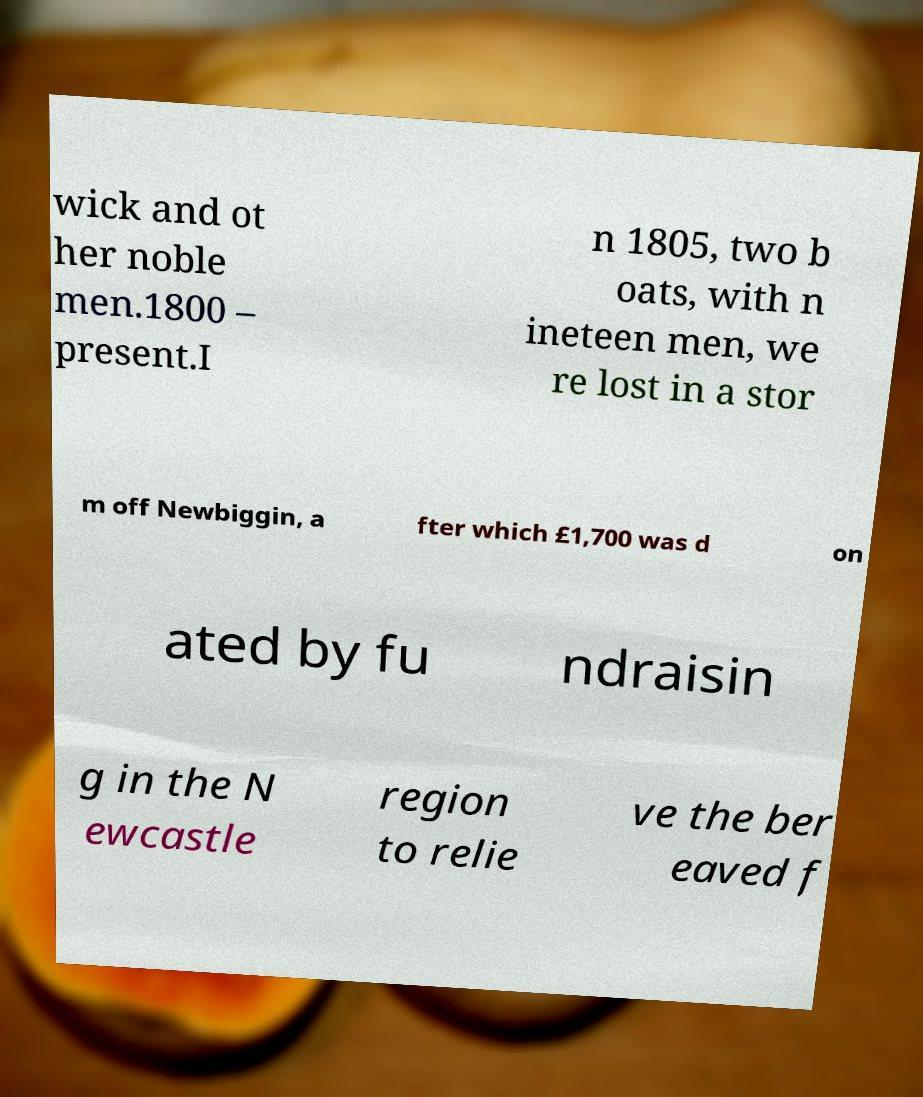I need the written content from this picture converted into text. Can you do that? wick and ot her noble men.1800 – present.I n 1805, two b oats, with n ineteen men, we re lost in a stor m off Newbiggin, a fter which £1,700 was d on ated by fu ndraisin g in the N ewcastle region to relie ve the ber eaved f 